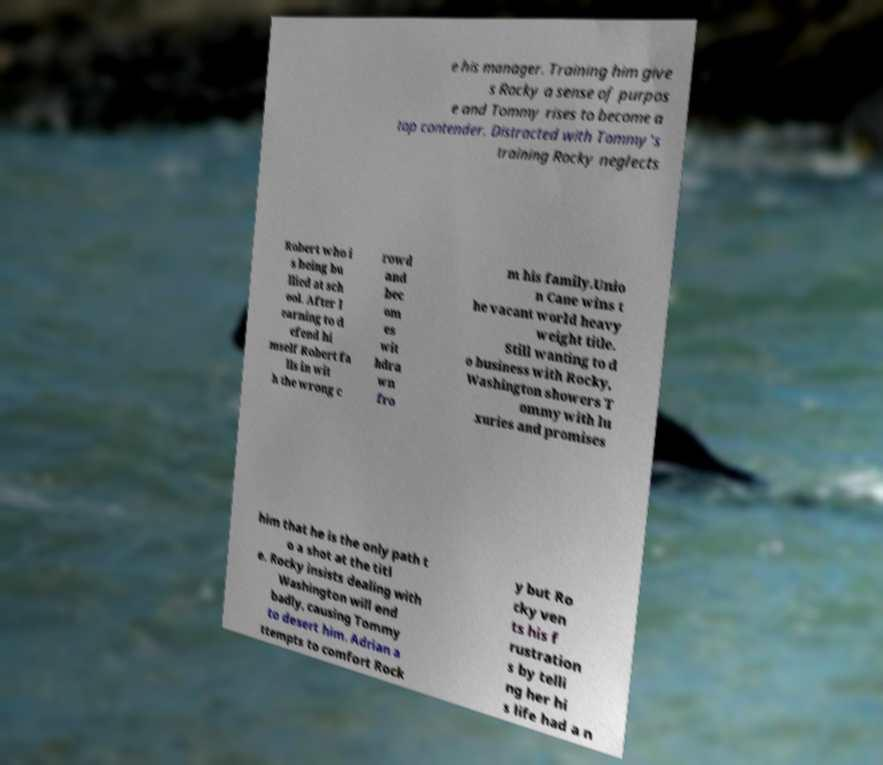For documentation purposes, I need the text within this image transcribed. Could you provide that? e his manager. Training him give s Rocky a sense of purpos e and Tommy rises to become a top contender. Distracted with Tommy's training Rocky neglects Robert who i s being bu llied at sch ool. After l earning to d efend hi mself Robert fa lls in wit h the wrong c rowd and bec om es wit hdra wn fro m his family.Unio n Cane wins t he vacant world heavy weight title. Still wanting to d o business with Rocky, Washington showers T ommy with lu xuries and promises him that he is the only path t o a shot at the titl e. Rocky insists dealing with Washington will end badly, causing Tommy to desert him. Adrian a ttempts to comfort Rock y but Ro cky ven ts his f rustration s by telli ng her hi s life had a n 